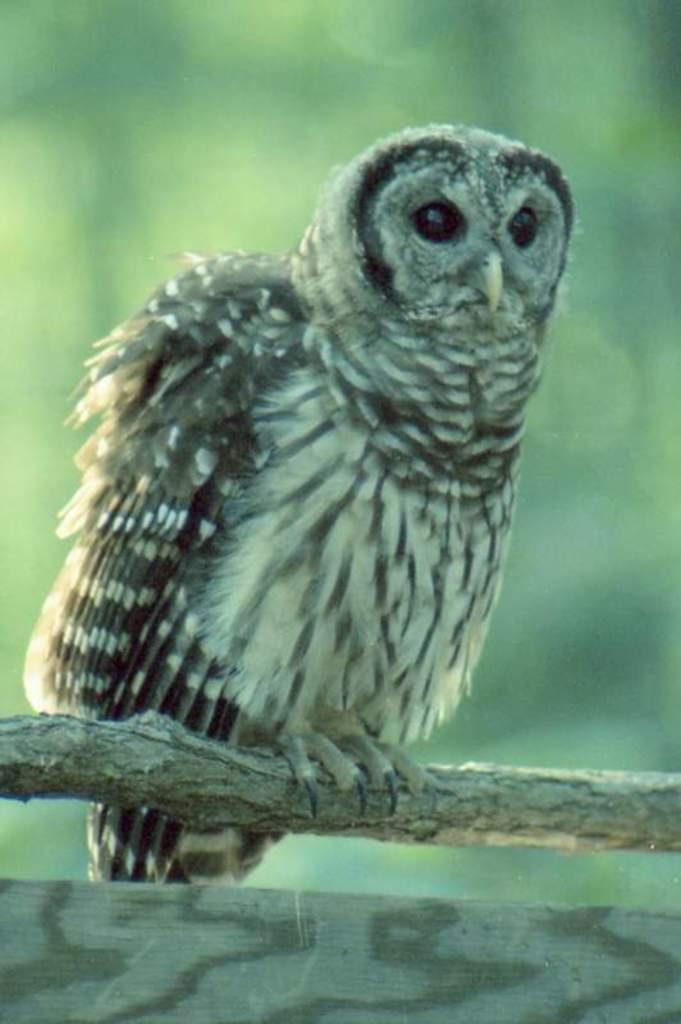What animal can be seen in the picture? There is an owl in the picture. Where is the owl located? The owl is sitting on a tree stem. What can be seen in the background of the picture? There are plants visible in the background, but they are not clearly visible. Can you tell me what the owl is saying to the plants in the image? Owls do not have the ability to talk, so there is no conversation between the owl and the plants in the image. 